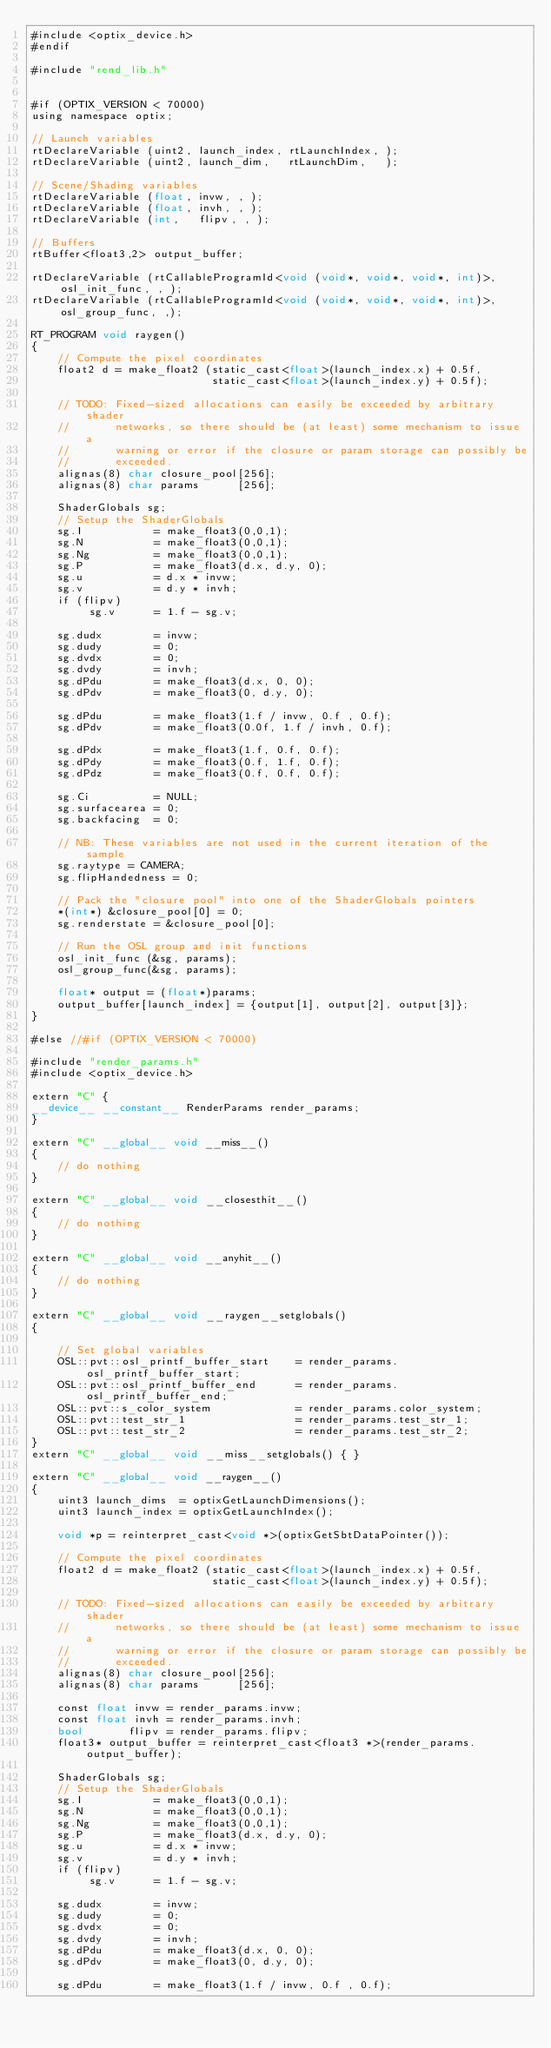<code> <loc_0><loc_0><loc_500><loc_500><_Cuda_>#include <optix_device.h>
#endif

#include "rend_lib.h"


#if (OPTIX_VERSION < 70000)
using namespace optix;

// Launch variables
rtDeclareVariable (uint2, launch_index, rtLaunchIndex, );
rtDeclareVariable (uint2, launch_dim,   rtLaunchDim,   );

// Scene/Shading variables
rtDeclareVariable (float, invw, , );
rtDeclareVariable (float, invh, , );
rtDeclareVariable (int,   flipv, , );

// Buffers
rtBuffer<float3,2> output_buffer;

rtDeclareVariable (rtCallableProgramId<void (void*, void*, void*, int)>, osl_init_func, , );
rtDeclareVariable (rtCallableProgramId<void (void*, void*, void*, int)>, osl_group_func, ,);

RT_PROGRAM void raygen()
{
    // Compute the pixel coordinates
    float2 d = make_float2 (static_cast<float>(launch_index.x) + 0.5f,
                            static_cast<float>(launch_index.y) + 0.5f);

    // TODO: Fixed-sized allocations can easily be exceeded by arbitrary shader
    //       networks, so there should be (at least) some mechanism to issue a
    //       warning or error if the closure or param storage can possibly be
    //       exceeded.
    alignas(8) char closure_pool[256];
    alignas(8) char params      [256];

    ShaderGlobals sg;
    // Setup the ShaderGlobals
    sg.I           = make_float3(0,0,1);
    sg.N           = make_float3(0,0,1);
    sg.Ng          = make_float3(0,0,1);
    sg.P           = make_float3(d.x, d.y, 0);
    sg.u           = d.x * invw;
    sg.v           = d.y * invh;
    if (flipv)
         sg.v      = 1.f - sg.v;

    sg.dudx        = invw;
    sg.dudy        = 0;
    sg.dvdx        = 0;
    sg.dvdy        = invh;
    sg.dPdu        = make_float3(d.x, 0, 0);
    sg.dPdv        = make_float3(0, d.y, 0);

    sg.dPdu        = make_float3(1.f / invw, 0.f , 0.f);
    sg.dPdv        = make_float3(0.0f, 1.f / invh, 0.f);

    sg.dPdx        = make_float3(1.f, 0.f, 0.f);
    sg.dPdy        = make_float3(0.f, 1.f, 0.f);
    sg.dPdz        = make_float3(0.f, 0.f, 0.f);

    sg.Ci          = NULL;
    sg.surfacearea = 0;
    sg.backfacing  = 0;

    // NB: These variables are not used in the current iteration of the sample
    sg.raytype = CAMERA;
    sg.flipHandedness = 0;

    // Pack the "closure pool" into one of the ShaderGlobals pointers
    *(int*) &closure_pool[0] = 0;
    sg.renderstate = &closure_pool[0];

    // Run the OSL group and init functions
    osl_init_func (&sg, params);
    osl_group_func(&sg, params);

    float* output = (float*)params;
    output_buffer[launch_index] = {output[1], output[2], output[3]};
}

#else //#if (OPTIX_VERSION < 70000)

#include "render_params.h"
#include <optix_device.h>

extern "C" {
__device__ __constant__ RenderParams render_params;
}

extern "C" __global__ void __miss__()
{
    // do nothing
}

extern "C" __global__ void __closesthit__()
{
    // do nothing
}

extern "C" __global__ void __anyhit__()
{
    // do nothing
}

extern "C" __global__ void __raygen__setglobals()
{

    // Set global variables
    OSL::pvt::osl_printf_buffer_start    = render_params.osl_printf_buffer_start;
    OSL::pvt::osl_printf_buffer_end      = render_params.osl_printf_buffer_end;
    OSL::pvt::s_color_system             = render_params.color_system;
    OSL::pvt::test_str_1                 = render_params.test_str_1;
    OSL::pvt::test_str_2                 = render_params.test_str_2;
}
extern "C" __global__ void __miss__setglobals() { }

extern "C" __global__ void __raygen__()
{
    uint3 launch_dims  = optixGetLaunchDimensions();
    uint3 launch_index = optixGetLaunchIndex();

    void *p = reinterpret_cast<void *>(optixGetSbtDataPointer());

    // Compute the pixel coordinates
    float2 d = make_float2 (static_cast<float>(launch_index.x) + 0.5f,
                            static_cast<float>(launch_index.y) + 0.5f);

    // TODO: Fixed-sized allocations can easily be exceeded by arbitrary shader
    //       networks, so there should be (at least) some mechanism to issue a
    //       warning or error if the closure or param storage can possibly be
    //       exceeded.
    alignas(8) char closure_pool[256];
    alignas(8) char params      [256];

    const float invw = render_params.invw;
    const float invh = render_params.invh;
    bool       flipv = render_params.flipv;
    float3* output_buffer = reinterpret_cast<float3 *>(render_params.output_buffer);

    ShaderGlobals sg;
    // Setup the ShaderGlobals
    sg.I           = make_float3(0,0,1);
    sg.N           = make_float3(0,0,1);
    sg.Ng          = make_float3(0,0,1);
    sg.P           = make_float3(d.x, d.y, 0);
    sg.u           = d.x * invw;
    sg.v           = d.y * invh;
    if (flipv)
         sg.v      = 1.f - sg.v;

    sg.dudx        = invw;
    sg.dudy        = 0;
    sg.dvdx        = 0;
    sg.dvdy        = invh;
    sg.dPdu        = make_float3(d.x, 0, 0);
    sg.dPdv        = make_float3(0, d.y, 0);

    sg.dPdu        = make_float3(1.f / invw, 0.f , 0.f);</code> 